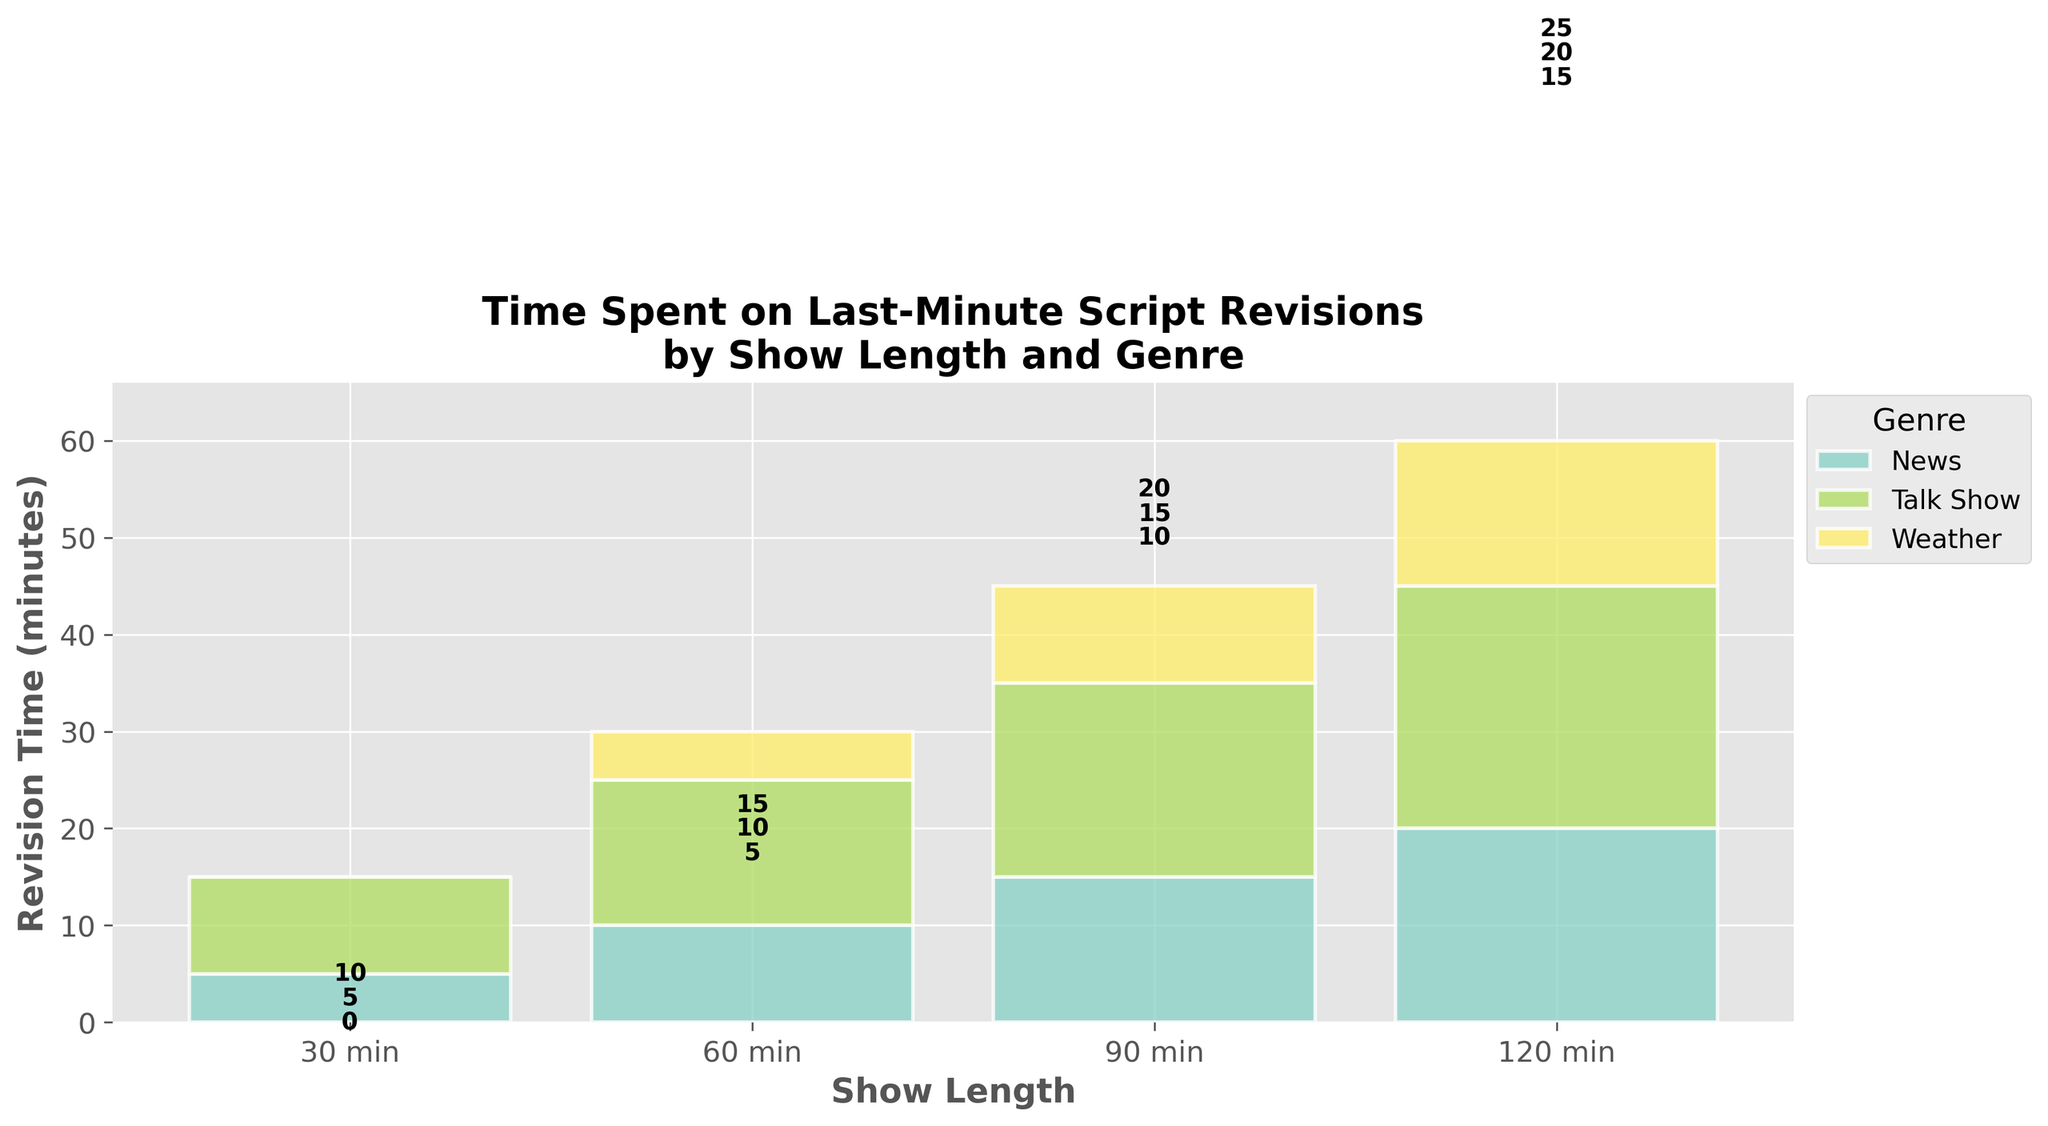What is the title of the plot? The title is located at the top of the plot. It provides a succinct summary of what the figure represents.
Answer: Time Spent on Last-Minute Script Revisions by Show Length and Genre How many genres are visualized in the plot? Count the number of distinct color-coded sections in the legend on the right side of the plot.
Answer: 3 What is the maximum revision time for a 60-minute Weather show? Identify the 60-minute marker on the x-axis, then find the corresponding section for Weather in the stacked bars. The height of this section will give the maximum revision time.
Answer: 5-10 min Which show length has the highest cumulative revision time across all genres? Compare the total heights of all stacked bars for each show length on the x-axis. The tallest bar represents the highest cumulative revision time.
Answer: 120 min How much more revision time does a 120-minute News show require compared to a 30-minute News show? Locate the heights of the News section for both 120-minute and 30-minute shows and take the difference. For 120 min it's 20-25 min and for 30 min it's 5-10 min. Calculate the lower bounds: 20 min - 5 min = 15 min. Also calculate the upper bounds: 25 min - 10 min = 15 min. Thus, the difference ranges from 15 min.
Answer: 15 min What is the average minimum revision time spent on Talk Shows across all show lengths? Extract the minimum revision times for Talk Shows at each show length and calculate their average: (10 min + 15 min + 20 min + 25 min )/4 = 17.5 min.
Answer: 17.5 min Which genre has the lowest revision time for 90-minute shows? Identify the 90-minute position on the x-axis and compare the heights of the segments for News, Talk Show, and Weather. The shortest segment corresponds to the lowest revision time.
Answer: Weather How does the revision time for 30-minute Talk Shows compare to 30-minute Weather shows? Locate the segments for Talk Show and Weather at the 30-minute mark and compare their heights.
Answer: Higher What is the combined minimum revision time for 60-minute and 90-minute News shows? Sum the minimum revision times for News shows of 60 minutes and 90 minutes: 10 min + 15 min = 25 min.
Answer: 25 min 